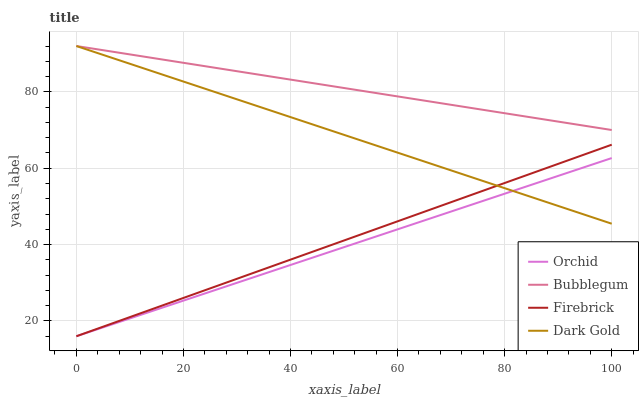Does Orchid have the minimum area under the curve?
Answer yes or no. Yes. Does Bubblegum have the maximum area under the curve?
Answer yes or no. Yes. Does Dark Gold have the minimum area under the curve?
Answer yes or no. No. Does Dark Gold have the maximum area under the curve?
Answer yes or no. No. Is Bubblegum the smoothest?
Answer yes or no. Yes. Is Dark Gold the roughest?
Answer yes or no. Yes. Is Dark Gold the smoothest?
Answer yes or no. No. Is Bubblegum the roughest?
Answer yes or no. No. Does Firebrick have the lowest value?
Answer yes or no. Yes. Does Dark Gold have the lowest value?
Answer yes or no. No. Does Bubblegum have the highest value?
Answer yes or no. Yes. Does Orchid have the highest value?
Answer yes or no. No. Is Orchid less than Bubblegum?
Answer yes or no. Yes. Is Bubblegum greater than Orchid?
Answer yes or no. Yes. Does Dark Gold intersect Orchid?
Answer yes or no. Yes. Is Dark Gold less than Orchid?
Answer yes or no. No. Is Dark Gold greater than Orchid?
Answer yes or no. No. Does Orchid intersect Bubblegum?
Answer yes or no. No. 